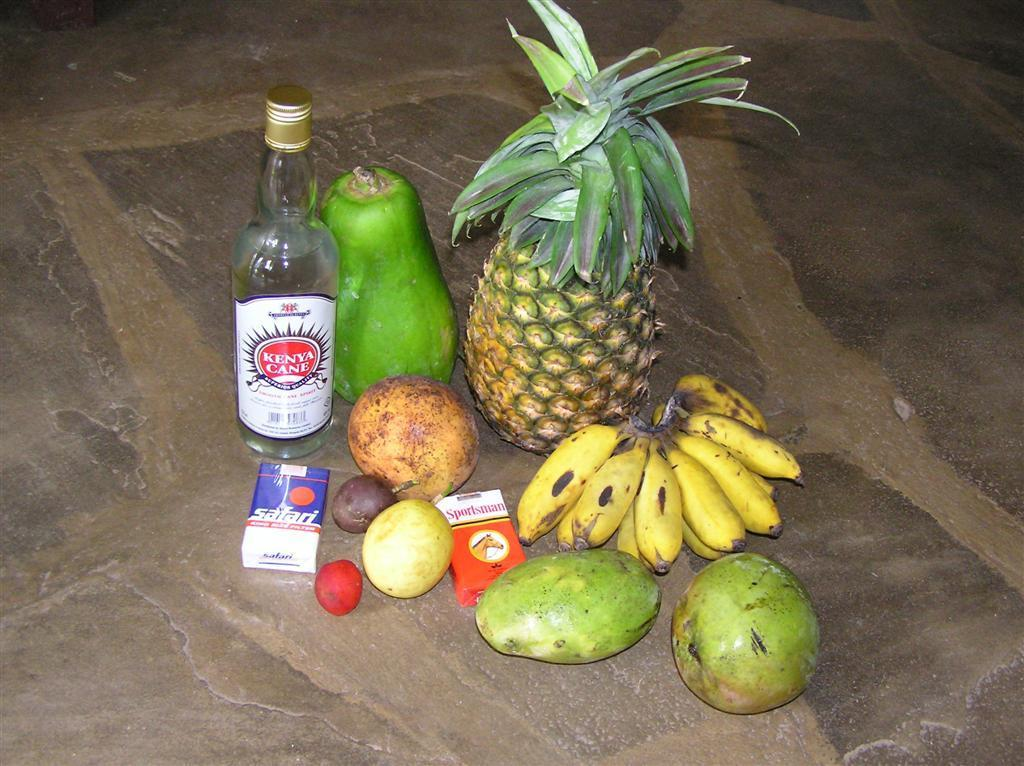What type of food items can be seen in the image? There are fruits in the image. What other object is present in the image? There is a bottle in the image. Are there any containers visible in the image? Yes, there are boxes in the image. Where are these objects located in the image? All of these objects are on the ground. How much earth can be seen in the image? There is no earth visible in the image; it only shows fruits, a bottle, and boxes on the ground. 